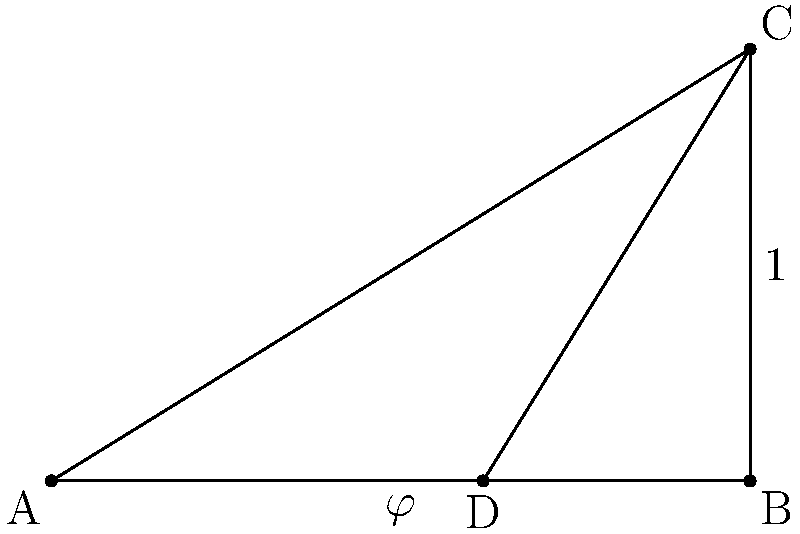In the architectural design of a prominent London building, a golden rectangle ABCD is used as a key element. If the longer side of the rectangle is 1 unit, what is the length of the shorter side in terms of the golden ratio $\varphi$? To solve this problem, let's follow these steps:

1) The golden ratio, denoted by $\varphi$ (phi), is defined as:

   $\varphi = \frac{a+b}{a} = \frac{a}{b}$

   where $a$ is the longer side and $b$ is the shorter side.

2) In our case, the longer side is given as 1 unit. Let's denote the shorter side as $x$.

3) According to the definition of the golden ratio:

   $\varphi = \frac{1}{x} = \frac{1+x}{1}$

4) From the second part of this equation:

   $\varphi = 1 + x$

5) Solving for $x$:

   $x = \varphi - 1$

6) A key property of the golden ratio is that:

   $\varphi^2 = \varphi + 1$

7) Dividing both sides by $\varphi$:

   $\varphi = 1 + \frac{1}{\varphi}$

8) Comparing this with our result from step 5, we can see that:

   $x = \frac{1}{\varphi}$

Therefore, the length of the shorter side of the golden rectangle is $\frac{1}{\varphi}$ units.
Answer: $\frac{1}{\varphi}$ 